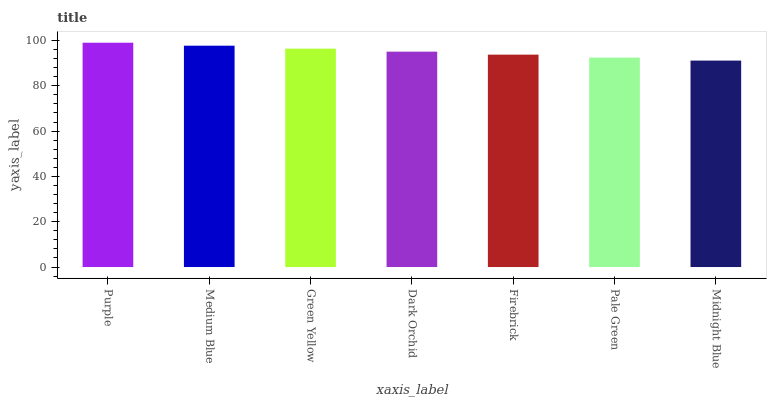Is Midnight Blue the minimum?
Answer yes or no. Yes. Is Purple the maximum?
Answer yes or no. Yes. Is Medium Blue the minimum?
Answer yes or no. No. Is Medium Blue the maximum?
Answer yes or no. No. Is Purple greater than Medium Blue?
Answer yes or no. Yes. Is Medium Blue less than Purple?
Answer yes or no. Yes. Is Medium Blue greater than Purple?
Answer yes or no. No. Is Purple less than Medium Blue?
Answer yes or no. No. Is Dark Orchid the high median?
Answer yes or no. Yes. Is Dark Orchid the low median?
Answer yes or no. Yes. Is Medium Blue the high median?
Answer yes or no. No. Is Medium Blue the low median?
Answer yes or no. No. 